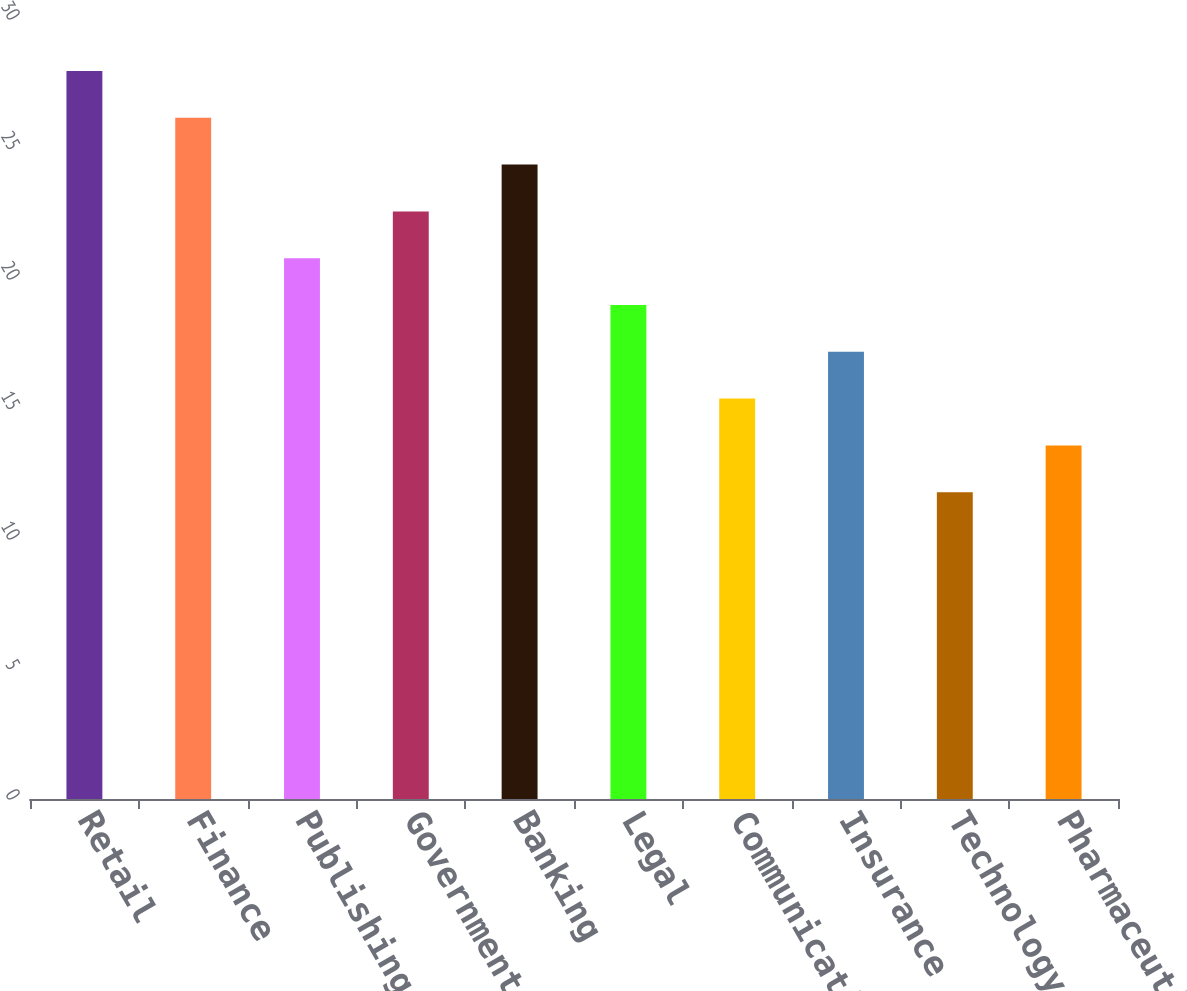Convert chart. <chart><loc_0><loc_0><loc_500><loc_500><bar_chart><fcel>Retail<fcel>Finance<fcel>Publishing<fcel>Government<fcel>Banking<fcel>Legal<fcel>Communications<fcel>Insurance<fcel>Technology<fcel>Pharmaceuticals<nl><fcel>28<fcel>26.2<fcel>20.8<fcel>22.6<fcel>24.4<fcel>19<fcel>15.4<fcel>17.2<fcel>11.8<fcel>13.6<nl></chart> 